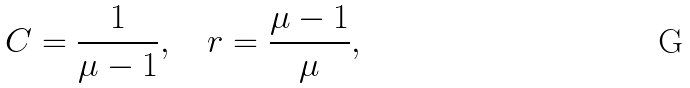Convert formula to latex. <formula><loc_0><loc_0><loc_500><loc_500>C = { \frac { 1 } { \mu - 1 } } , \quad r = { \frac { \mu - 1 } { \mu } } ,</formula> 